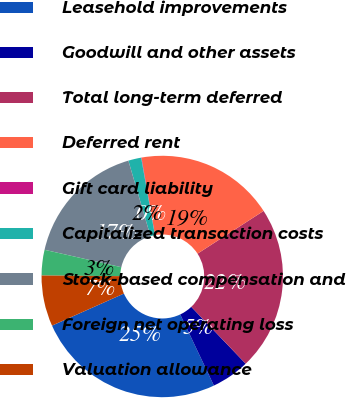Convert chart to OTSL. <chart><loc_0><loc_0><loc_500><loc_500><pie_chart><fcel>Leasehold improvements<fcel>Goodwill and other assets<fcel>Total long-term deferred<fcel>Deferred rent<fcel>Gift card liability<fcel>Capitalized transaction costs<fcel>Stock-based compensation and<fcel>Foreign net operating loss<fcel>Valuation allowance<nl><fcel>25.36%<fcel>5.11%<fcel>21.99%<fcel>18.61%<fcel>0.05%<fcel>1.73%<fcel>16.92%<fcel>3.42%<fcel>6.8%<nl></chart> 